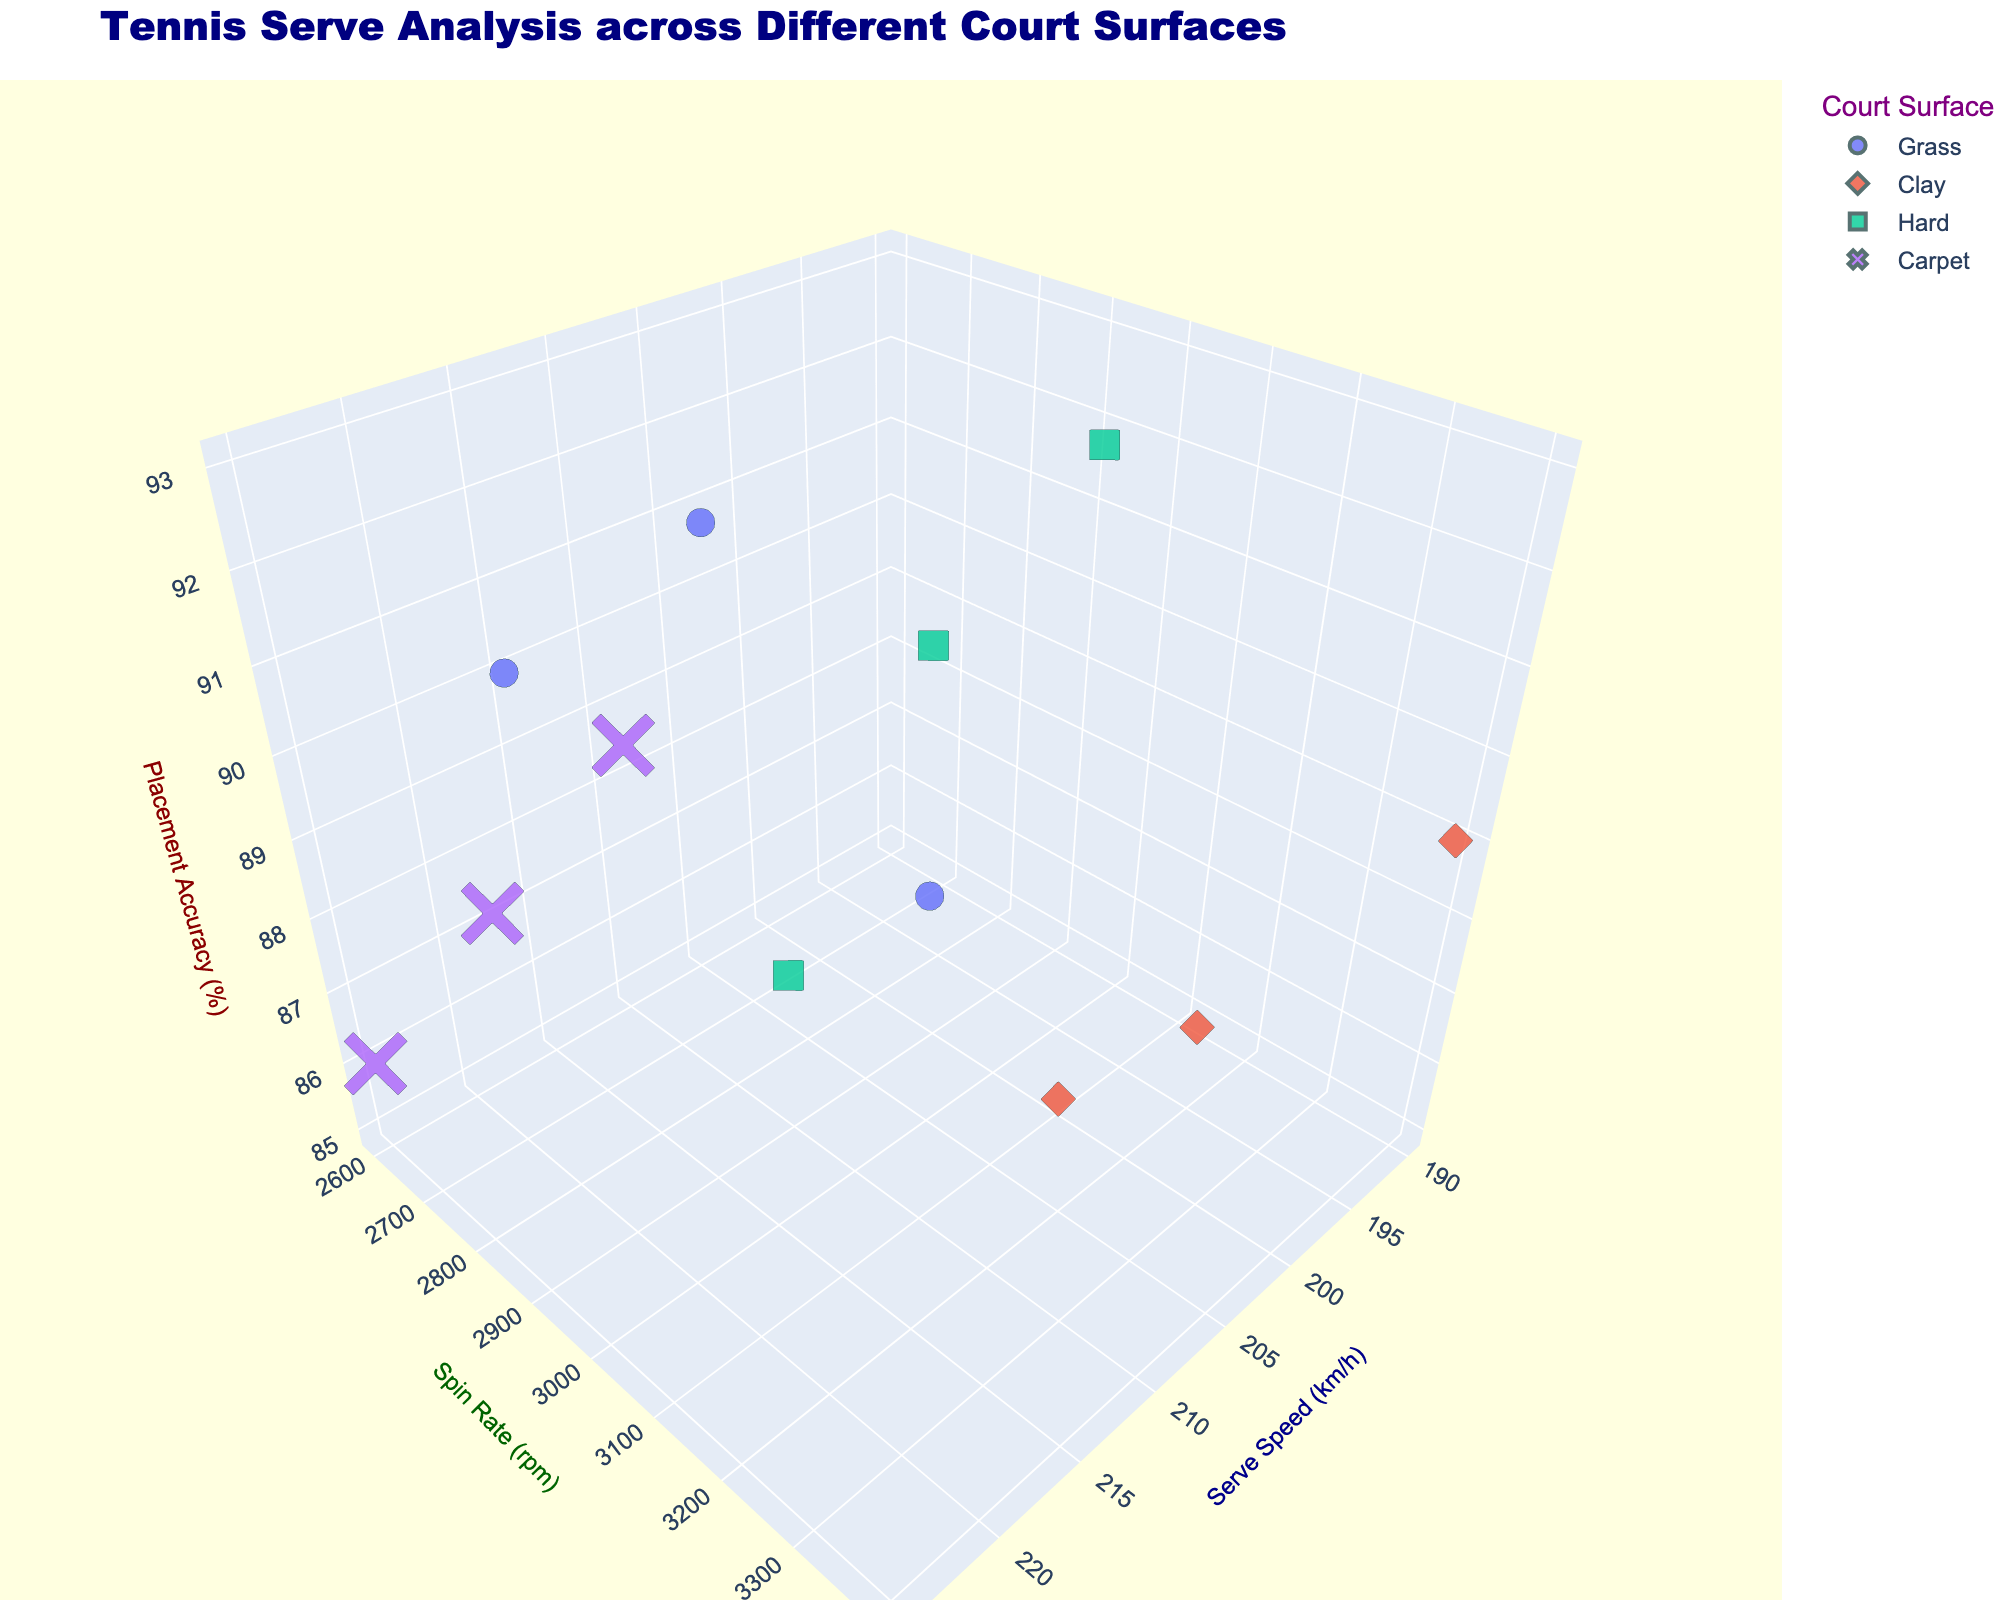How many surfaces are represented in the plot? To determine the number of surfaces, locate the legend of the plot which indicates different surfaces by color and symbol. Count the unique entries.
Answer: 4 What is the serve speed range for Grass surfaces? Find the data points labeled as Grass in the legend, then observe the Serve Speed (km/h) axis. Identify the minimum and maximum values represented by Grass points.
Answer: 205-215 km/h Which surface has the highest serve speed overall? Identify the maximum serve speed value on the Serve Speed (km/h) axis and check which color/symbol it corresponds to, as indicated by the legend for surface types.
Answer: Carpet What is the average placement accuracy for serves on Clay? First, find the data points for Clay serves using the legend. Read their placement accuracy values, and calculate their average: (86 + 89 + 85) / 3.
Answer: 86.67% Is there a relationship between serve speed and spin rate for Hard surfaces? Observe the data points for Hard surface in the figure to see if there's a pattern or trend between the Serve Speed (km/h) and Spin Rate (rpm) axes. Signs of a relationship can include a visible trend such as increasing or decreasing together, clustering, etc.
Answer: No clear relationship Which surface has the most consistent placement accuracy? For each surface type, look at the distribution of data points along the Placement Accuracy (%) axis. The surface with the smallest spread in these values is the most consistent.
Answer: Hard Between Grass and Clay, which has higher spin rates on average? Calculate the average spin rate for Grass (2800 + 3000 + 2600) / 3 and for Clay (3200 + 3400 + 3100) / 3. Compare the two averages to see which one is higher.
Answer: Clay Compare the maximum placement accuracy between Hard and Carpet surfaces. Identify the highest placement accuracy values for each surface type by looking at the Placement Accuracy (%) axis. Compare these maximum values.
Answer: Hard (93%) vs Carpet (90%) How does the serve speed on Grass compare to the serve speed on Carpet? Compare the serve speed ranges for Grass (205-215 km/h) and Carpet (215-225 km/h) by looking at the Serve Speed (km/h) axis and noting the overlap and differences in values.
Answer: Carpet serves are generally faster What's the median spin rate for serves on Hard surfaces? Identify spin rate values for Hard serves (3000, 2900, 3100). Arrange these values in ascending order and find the median value.
Answer: 3000 rpm 